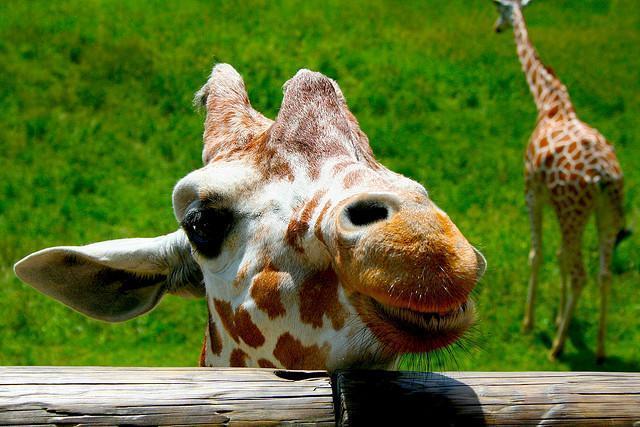How many ears does the main giraffe likely have?
Give a very brief answer. 2. How many giraffes are in the picture?
Give a very brief answer. 2. How many of the people sitting have a laptop on there lap?
Give a very brief answer. 0. 